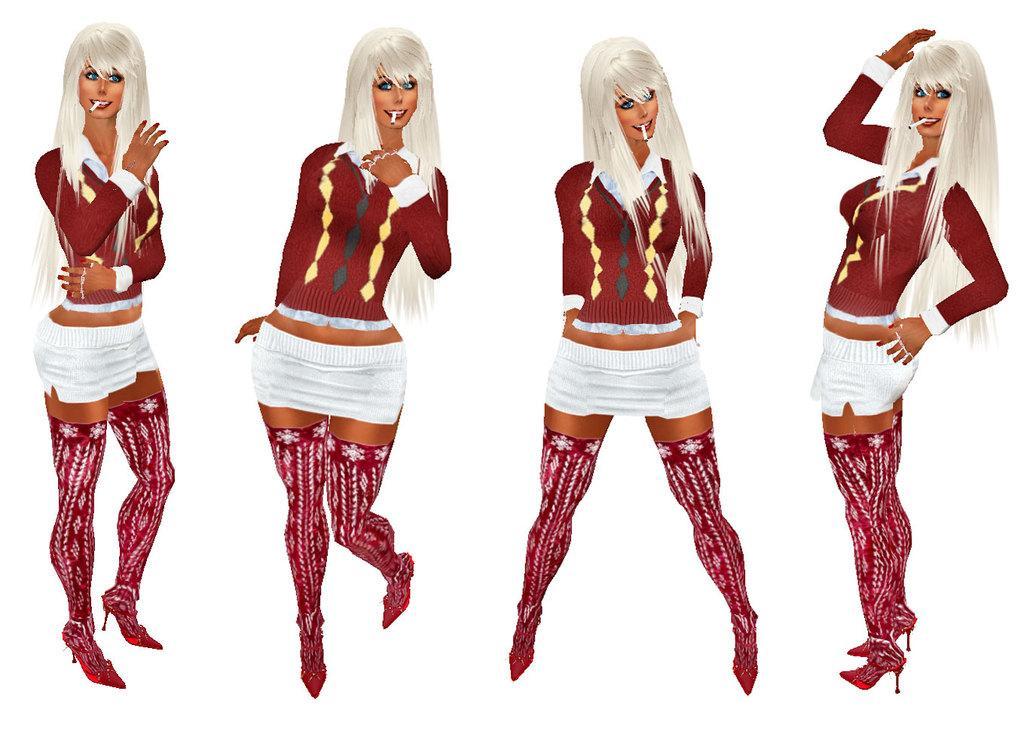Could you give a brief overview of what you see in this image? In this picture we can see cartoon images of four women and in the background we can see it is white color. 